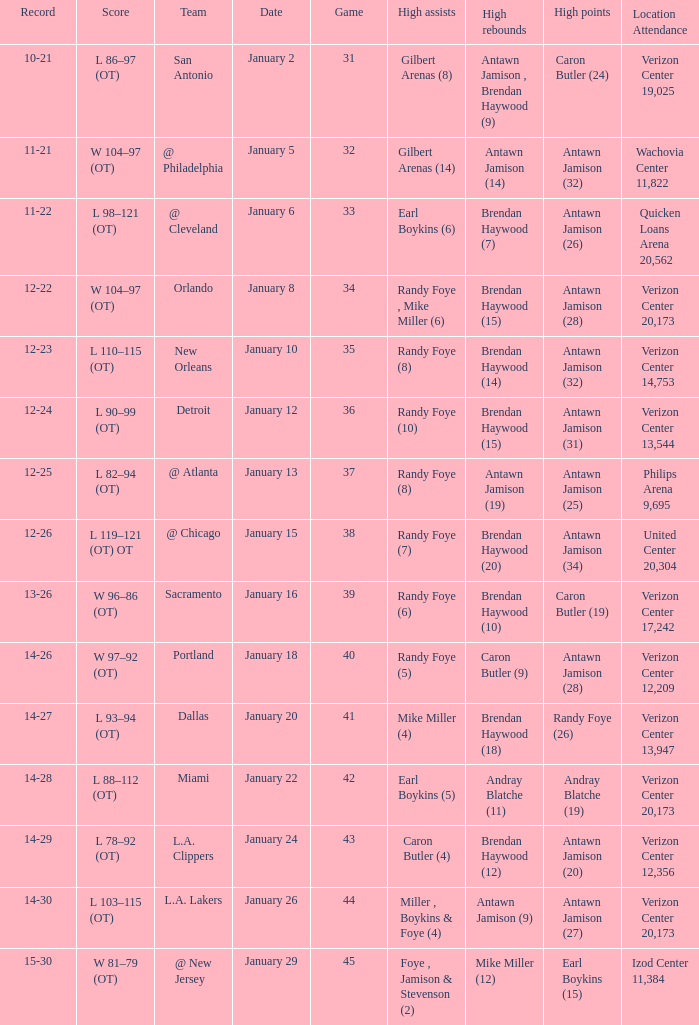What day was the record 14-27? January 20. 